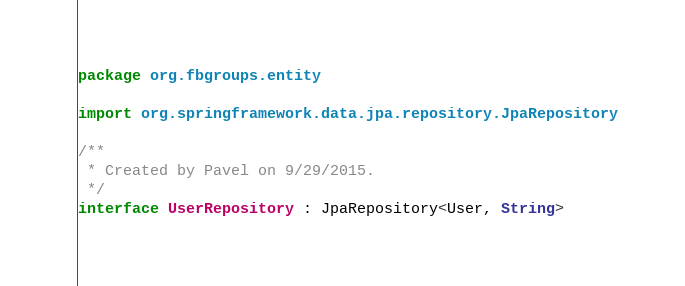<code> <loc_0><loc_0><loc_500><loc_500><_Kotlin_>package org.fbgroups.entity

import org.springframework.data.jpa.repository.JpaRepository

/**
 * Created by Pavel on 9/29/2015.
 */
interface UserRepository : JpaRepository<User, String>
</code> 